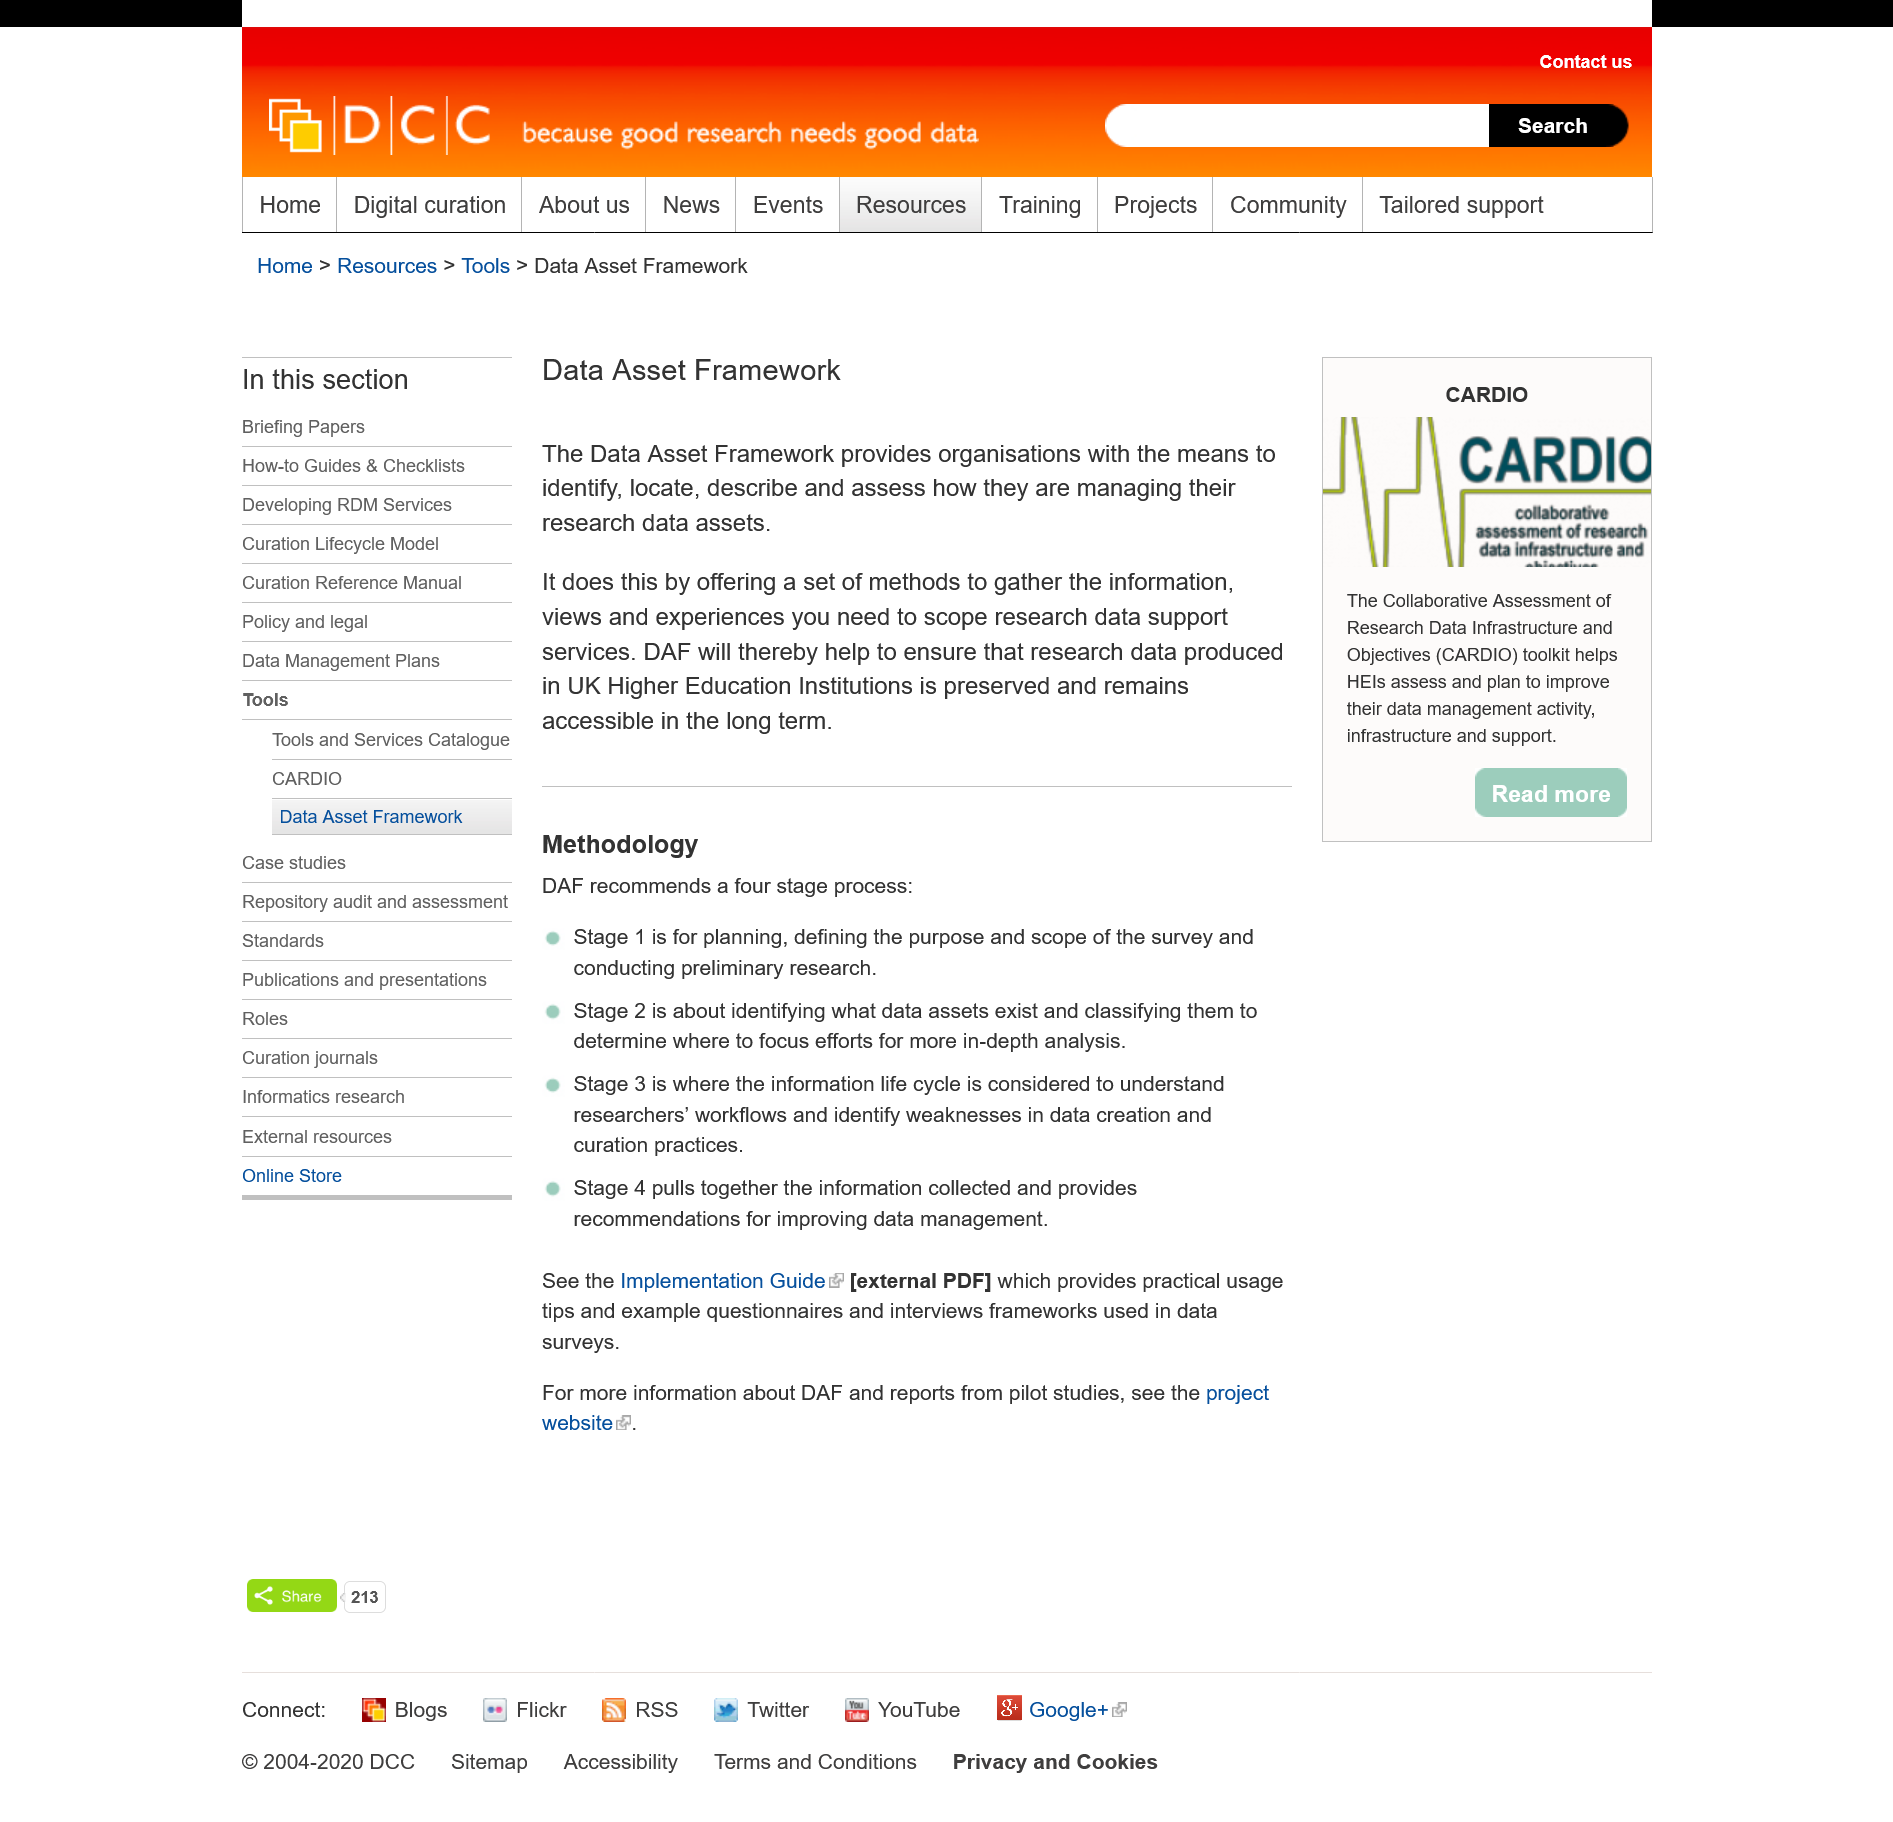Identify some key points in this picture. The entity that provides a set of methods for gathering the information required to scope research data support services is the Digital Asset Framework (DAF). The acronym DAF stands for Data Asset Framework, which refers to a system or set of guidelines that helps organizations manage and organize their data assets. The Data Asset Framework enables organizations to determine their approach towards managing research data assets. 